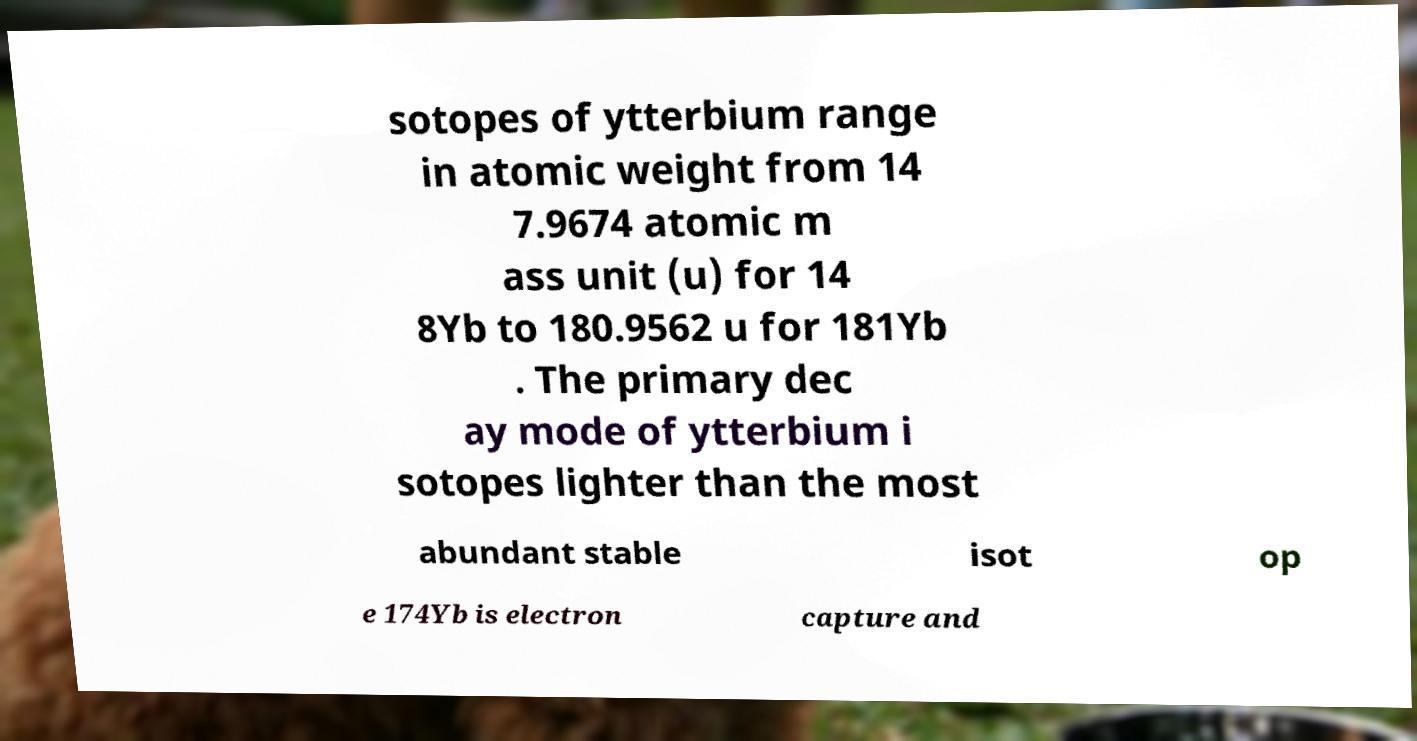Can you accurately transcribe the text from the provided image for me? sotopes of ytterbium range in atomic weight from 14 7.9674 atomic m ass unit (u) for 14 8Yb to 180.9562 u for 181Yb . The primary dec ay mode of ytterbium i sotopes lighter than the most abundant stable isot op e 174Yb is electron capture and 